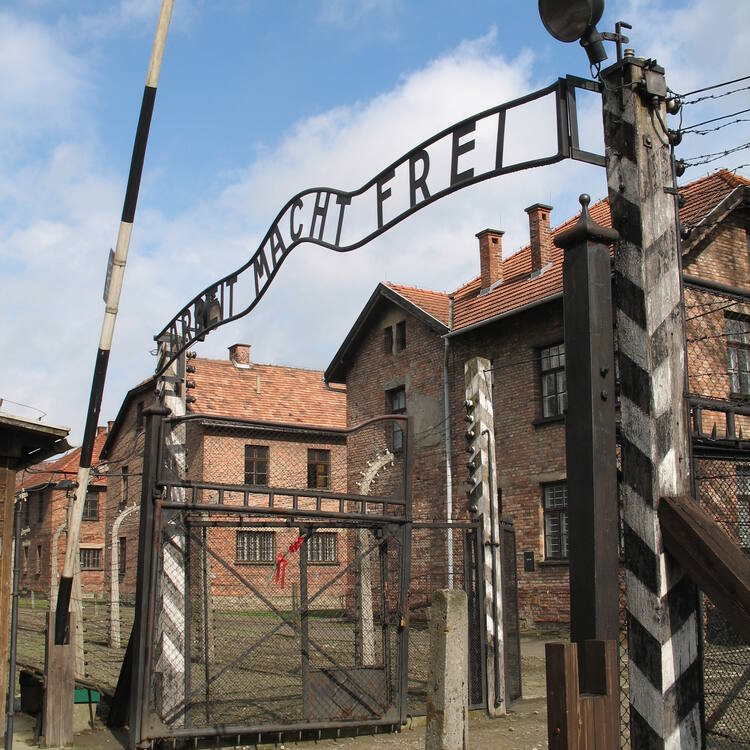Can you explain the significance of the inscription on the gate? The inscription on the gate reads "Arbeit Macht Frei", a German phrase meaning "Work sets you free". This cynical slogan was placed at the entrances of several Nazi concentration camps, including Auschwitz. It was intended to deceive the prisoners about the true nature of the camps and to imply that hard work could lead to their freedom, which was a cruel lie as the camps were primarily centers of forced labor, inhumane treatment, and mass extermination. 